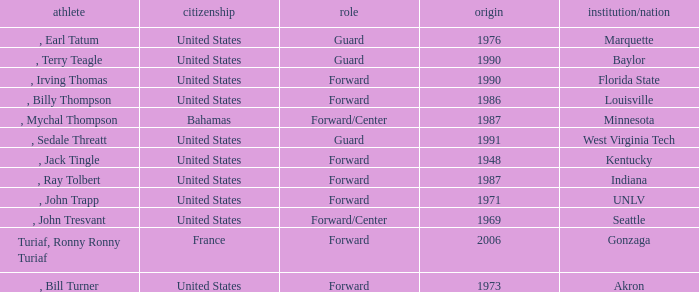What was the nationality of all players from the year 1976? United States. 